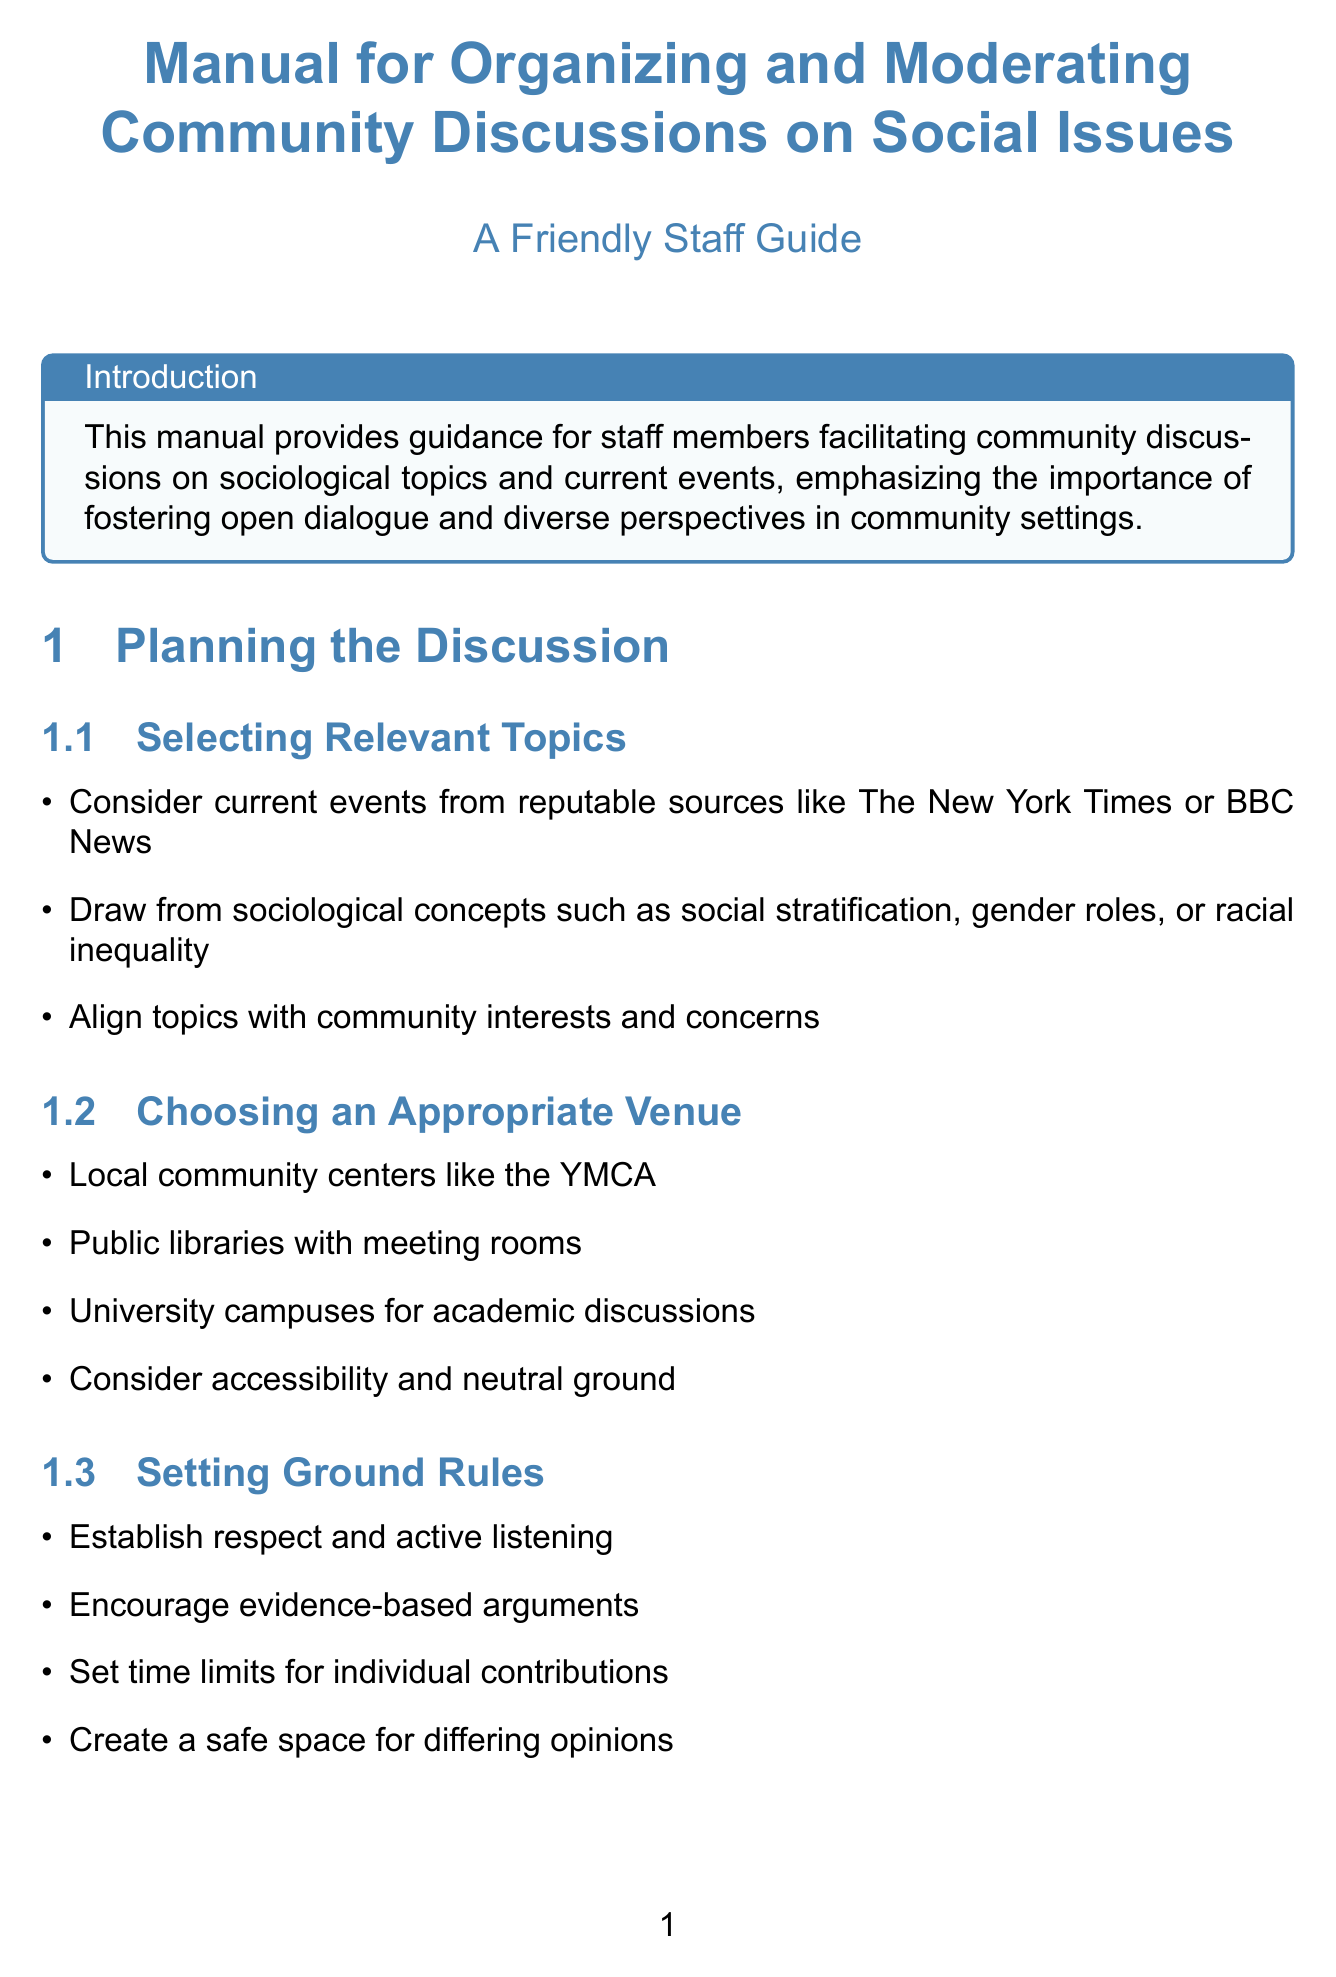what is the purpose of the manual? The purpose is to provide guidance for staff members facilitating community discussions on sociological topics and current events.
Answer: guidance for staff members facilitating community discussions on sociological topics and current events which chapter discusses setting ground rules? The section on setting ground rules is found within the chapter on planning the discussion.
Answer: Planning the Discussion name a type of venue suggested for discussions. A suggested venue type is public libraries with meeting rooms.
Answer: public libraries with meeting rooms how can facilitators invite diverse participants? Facilitators can invite diverse participants by partnering with community leaders from different backgrounds.
Answer: partner with community leaders from different backgrounds what is a technique suggested for managing conflicting viewpoints? One technique is to use active listening techniques to acknowledge all perspectives.
Answer: use active listening techniques to acknowledge all perspectives according to the manual, what should be summarized in the conclusion? In the conclusion, main arguments and counterarguments should be summarized.
Answer: main arguments and counterarguments what resource is listed in the appendices? One resource listed is the American Sociological Association (ASA) website.
Answer: American Sociological Association (ASA) website how many sample discussion topics are provided in the appendices? Four sample discussion topics are provided in the appendices.
Answer: four 